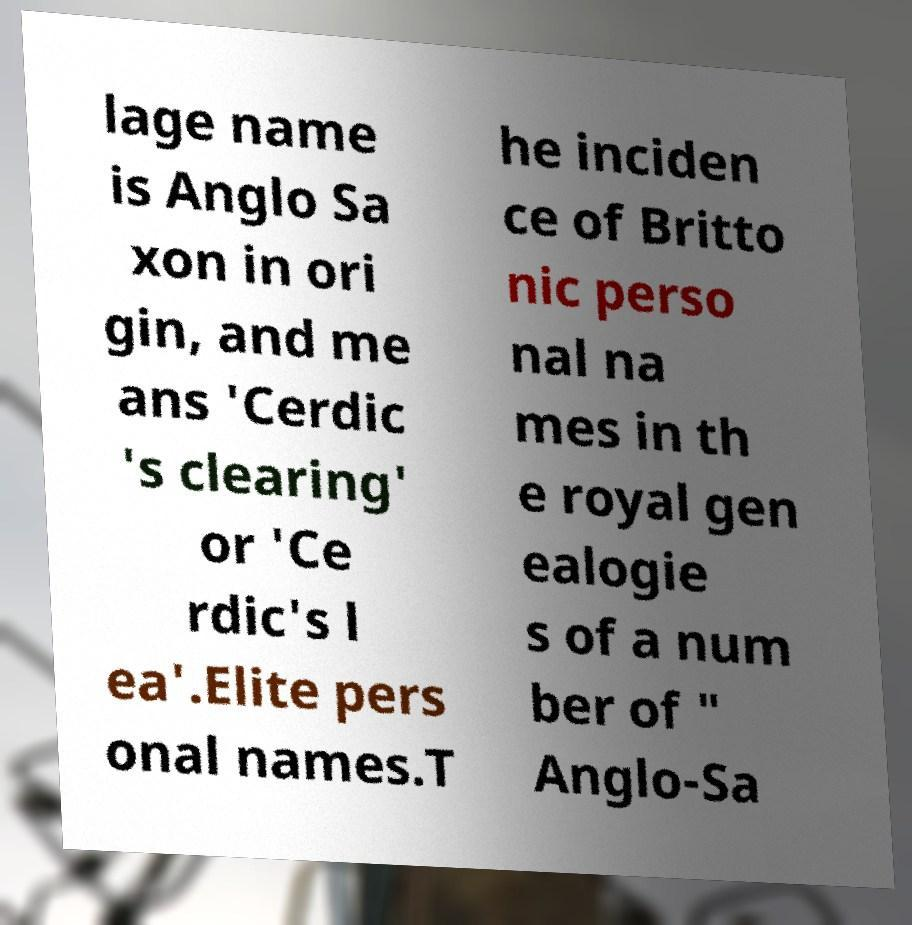Can you read and provide the text displayed in the image?This photo seems to have some interesting text. Can you extract and type it out for me? lage name is Anglo Sa xon in ori gin, and me ans 'Cerdic 's clearing' or 'Ce rdic's l ea'.Elite pers onal names.T he inciden ce of Britto nic perso nal na mes in th e royal gen ealogie s of a num ber of " Anglo-Sa 